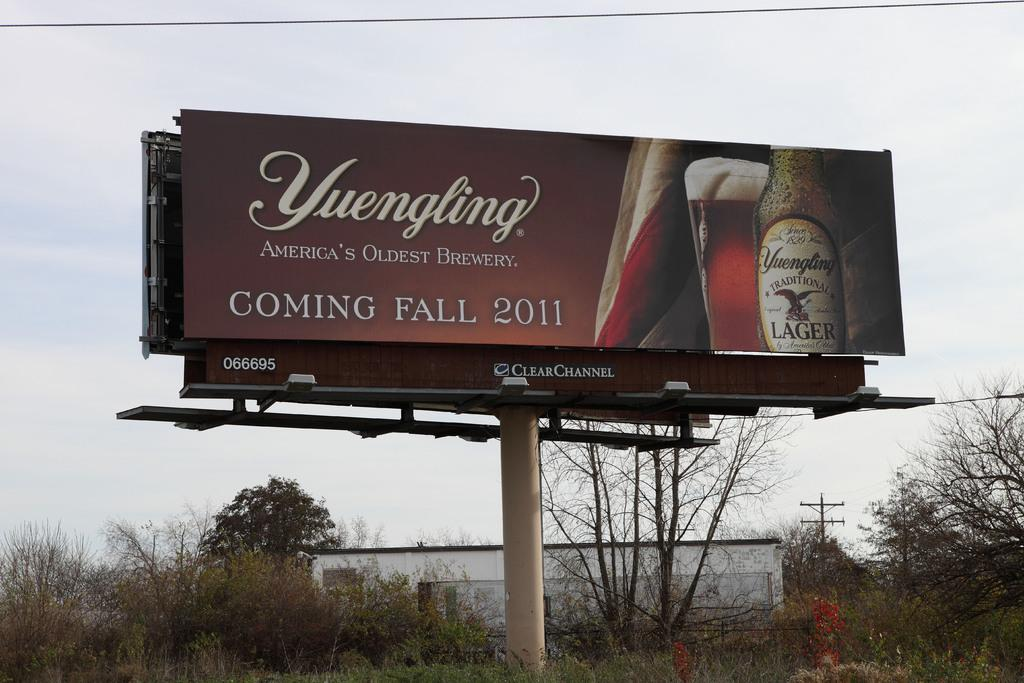<image>
Share a concise interpretation of the image provided. a large Yuengling beer sign says it is coming Fall 2011 